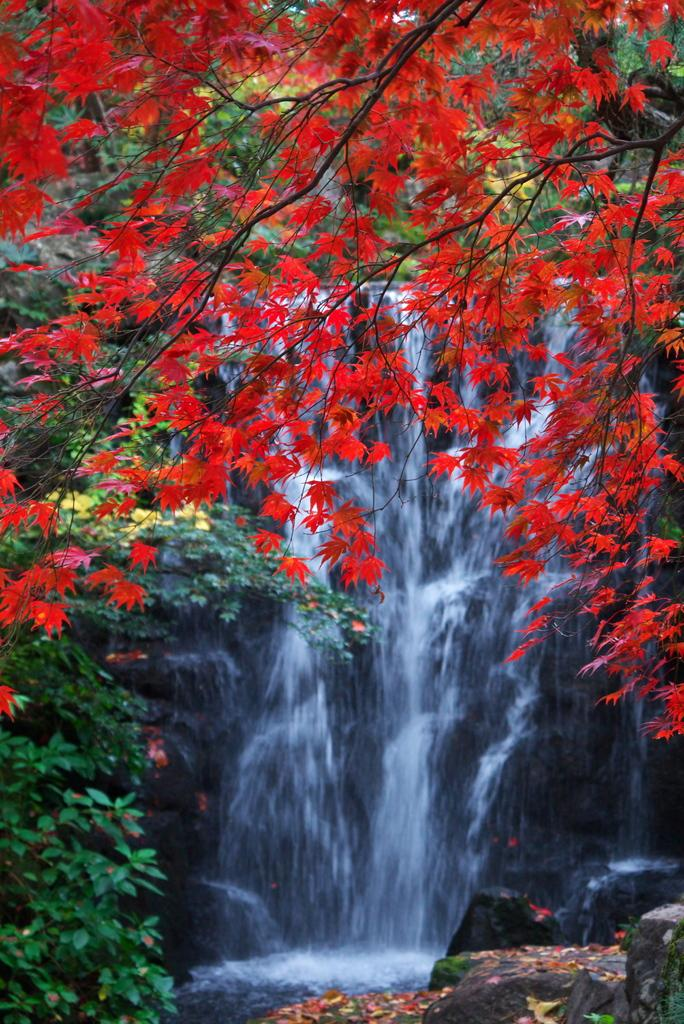What is the primary element visible in the image? There is water in the image. What type of vegetation can be seen in the image? There are trees in the image. What other objects or features are present in the image? There are rocks in the image. What type of pets can be seen playing with a pail in the image? There are no pets or pails present in the image. 